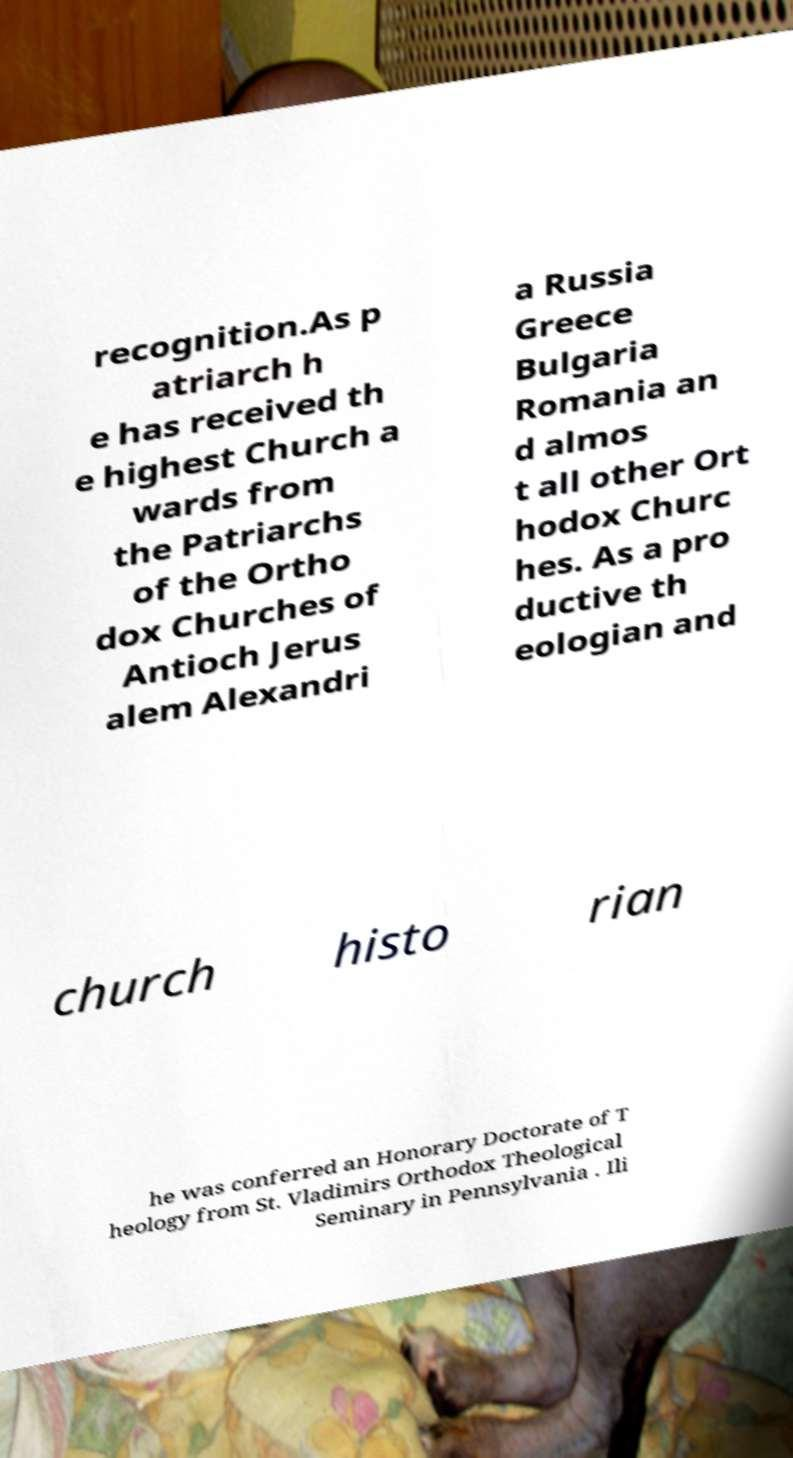I need the written content from this picture converted into text. Can you do that? recognition.As p atriarch h e has received th e highest Church a wards from the Patriarchs of the Ortho dox Churches of Antioch Jerus alem Alexandri a Russia Greece Bulgaria Romania an d almos t all other Ort hodox Churc hes. As a pro ductive th eologian and church histo rian he was conferred an Honorary Doctorate of T heology from St. Vladimirs Orthodox Theological Seminary in Pennsylvania . Ili 